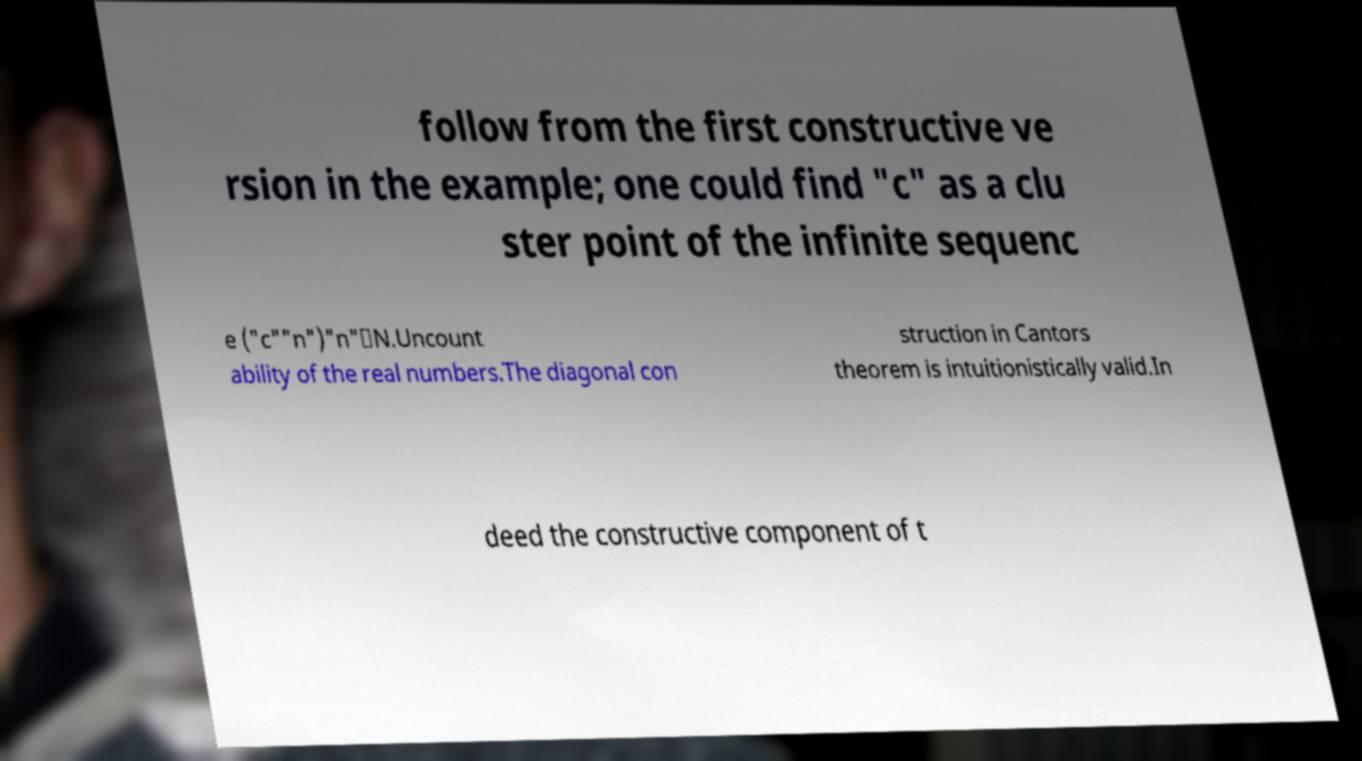Can you read and provide the text displayed in the image?This photo seems to have some interesting text. Can you extract and type it out for me? follow from the first constructive ve rsion in the example; one could find "c" as a clu ster point of the infinite sequenc e ("c""n")"n"∈N.Uncount ability of the real numbers.The diagonal con struction in Cantors theorem is intuitionistically valid.In deed the constructive component of t 